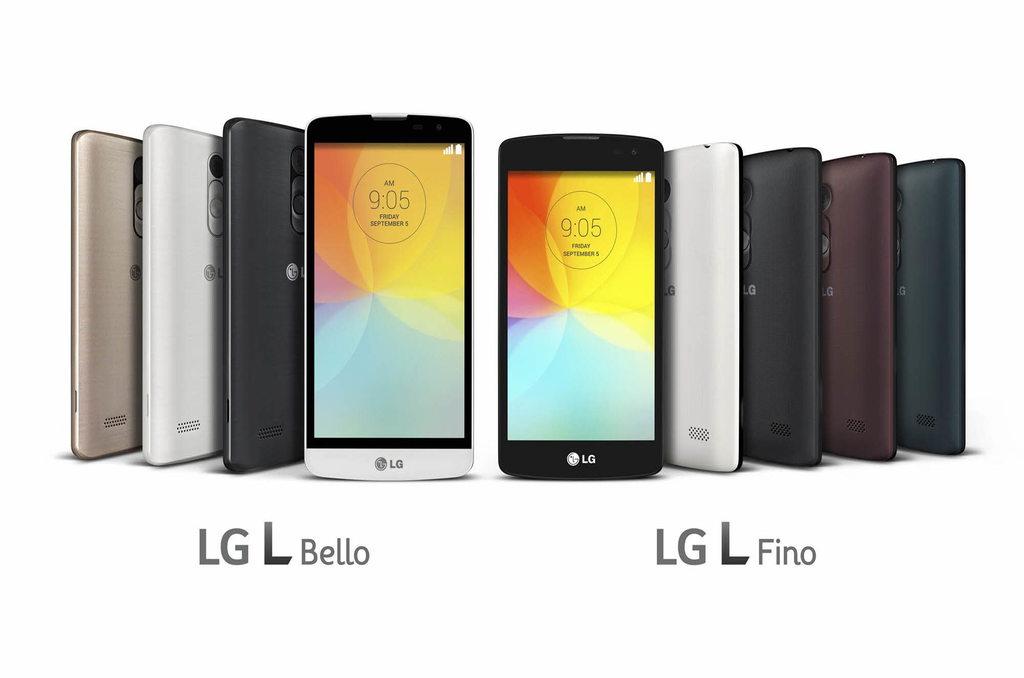What phone is this?
Your answer should be compact. Lg. 